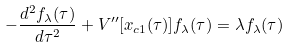<formula> <loc_0><loc_0><loc_500><loc_500>- \frac { d ^ { 2 } f _ { \lambda } ( \tau ) } { d \tau ^ { 2 } } + V ^ { \prime \prime } [ x _ { c 1 } ( \tau ) ] f _ { \lambda } ( \tau ) = \lambda f _ { \lambda } ( \tau )</formula> 